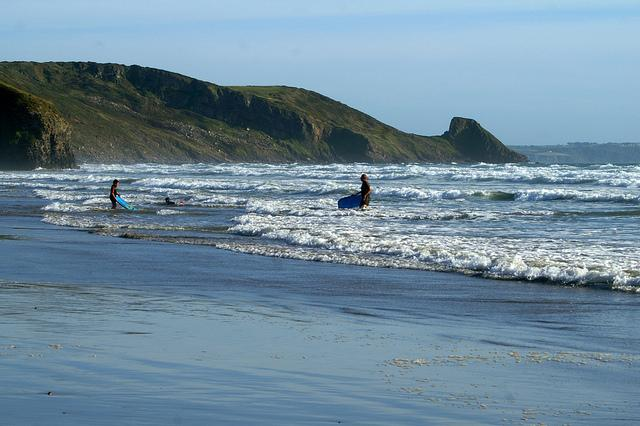What animal can usually be found here? Please explain your reasoning. fish. The beach is surrounded by water that is full of different kinds of fish. 